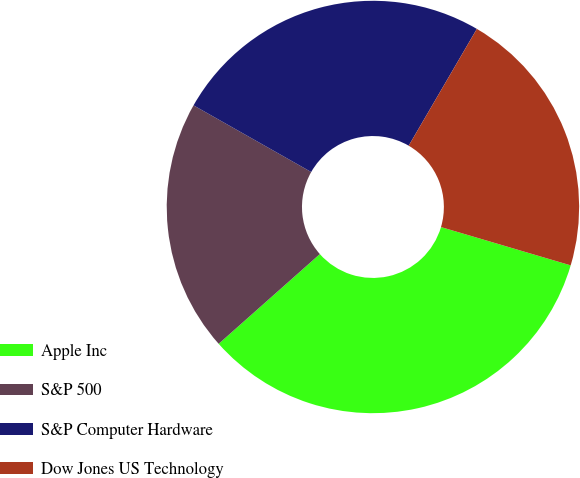Convert chart. <chart><loc_0><loc_0><loc_500><loc_500><pie_chart><fcel>Apple Inc<fcel>S&P 500<fcel>S&P Computer Hardware<fcel>Dow Jones US Technology<nl><fcel>33.88%<fcel>19.75%<fcel>25.2%<fcel>21.16%<nl></chart> 